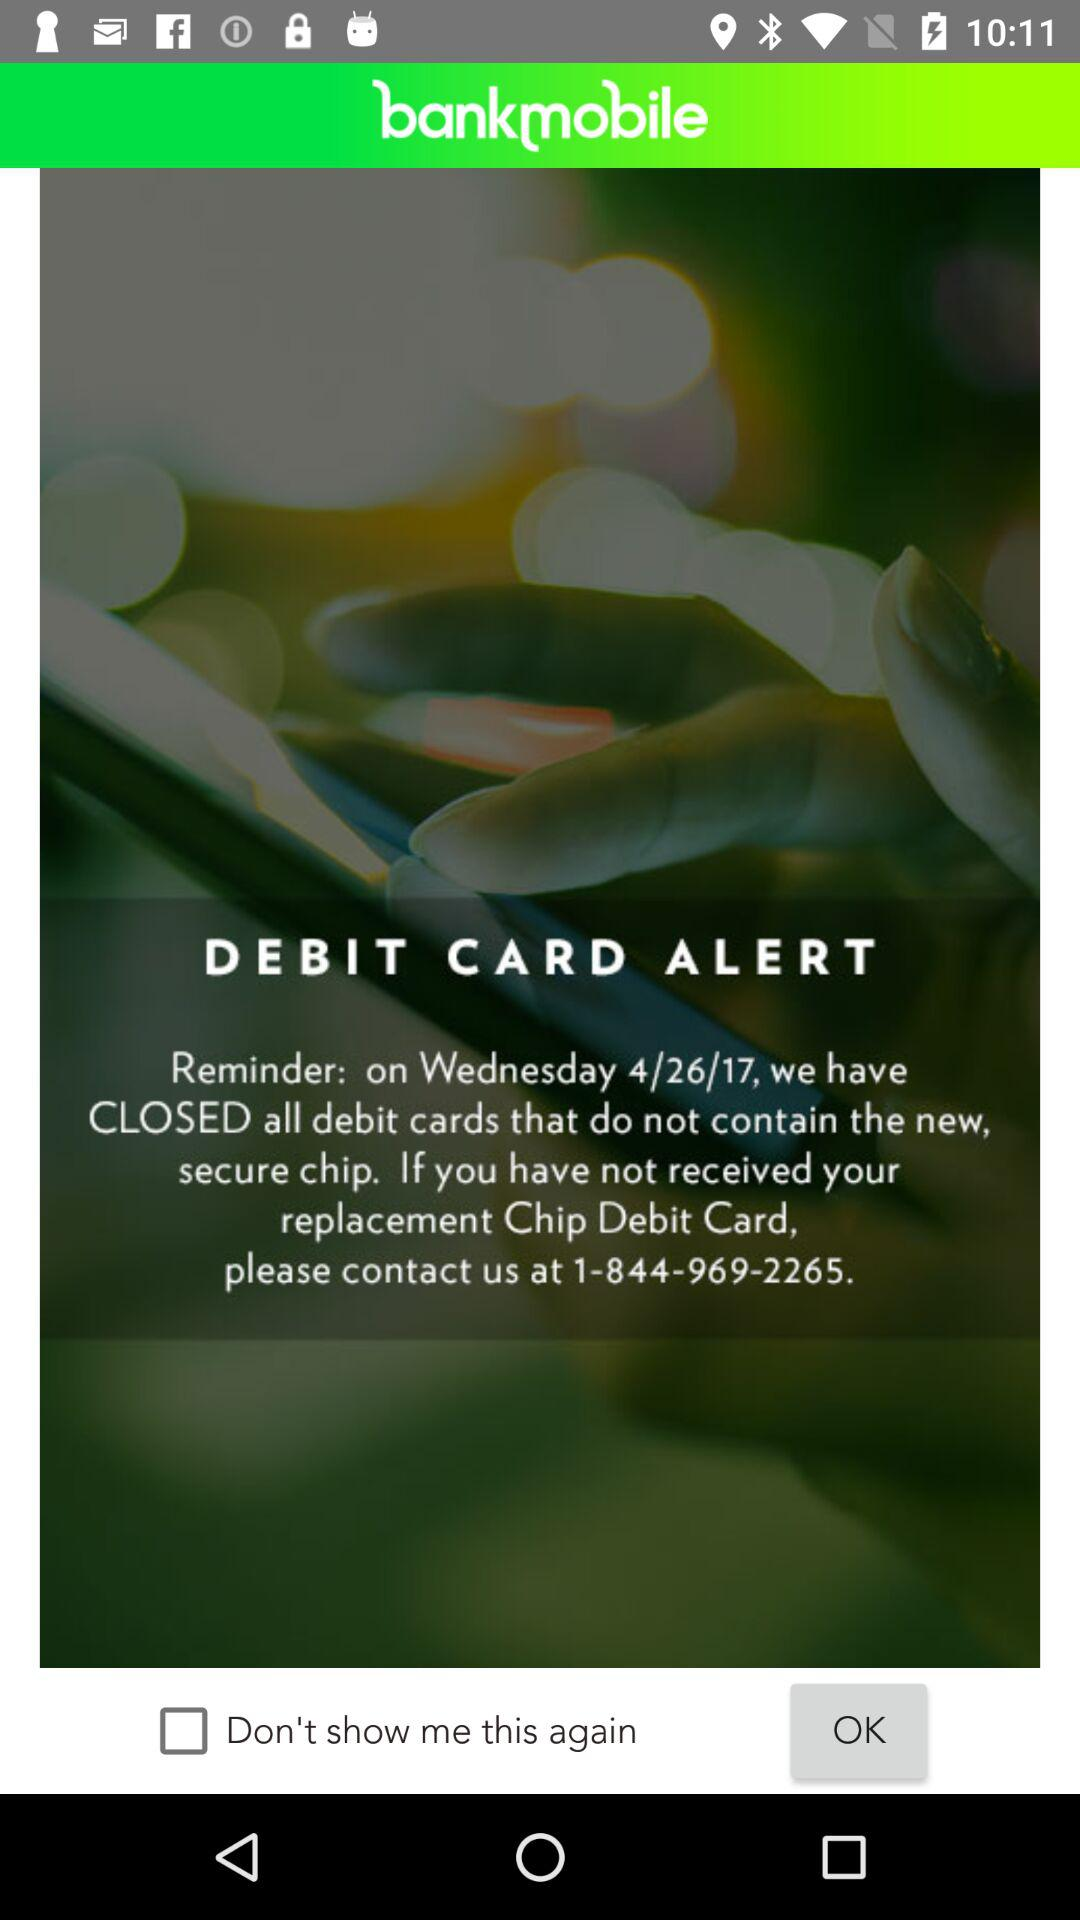What is the customer care contact number? The contact number is 1-844-969-2265. 